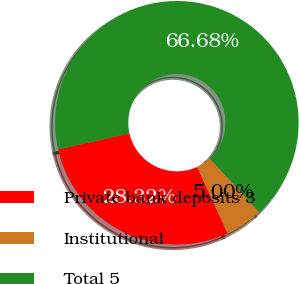Convert chart to OTSL. <chart><loc_0><loc_0><loc_500><loc_500><pie_chart><fcel>Private bank deposits 3<fcel>Institutional<fcel>Total 5<nl><fcel>28.32%<fcel>5.0%<fcel>66.68%<nl></chart> 